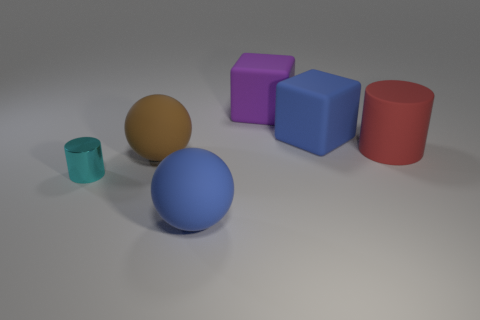Do the large purple rubber thing behind the tiny metallic cylinder and the cyan thing have the same shape?
Give a very brief answer. No. There is a blue thing in front of the large rubber sphere behind the matte thing that is in front of the small cyan thing; what is its shape?
Ensure brevity in your answer.  Sphere. What material is the cylinder that is in front of the red rubber thing?
Make the answer very short. Metal. There is a rubber cylinder that is the same size as the blue cube; what color is it?
Offer a terse response. Red. How many other objects are the same shape as the cyan thing?
Your response must be concise. 1. Do the purple rubber thing and the shiny object have the same size?
Ensure brevity in your answer.  No. Is the number of big brown rubber spheres right of the big brown matte thing greater than the number of blue rubber objects behind the blue matte sphere?
Offer a terse response. No. How many other objects are there of the same size as the brown rubber ball?
Your response must be concise. 4. Are there more matte things on the right side of the big brown rubber thing than green shiny objects?
Make the answer very short. Yes. Is there any other thing of the same color as the tiny metallic thing?
Your answer should be very brief. No. 